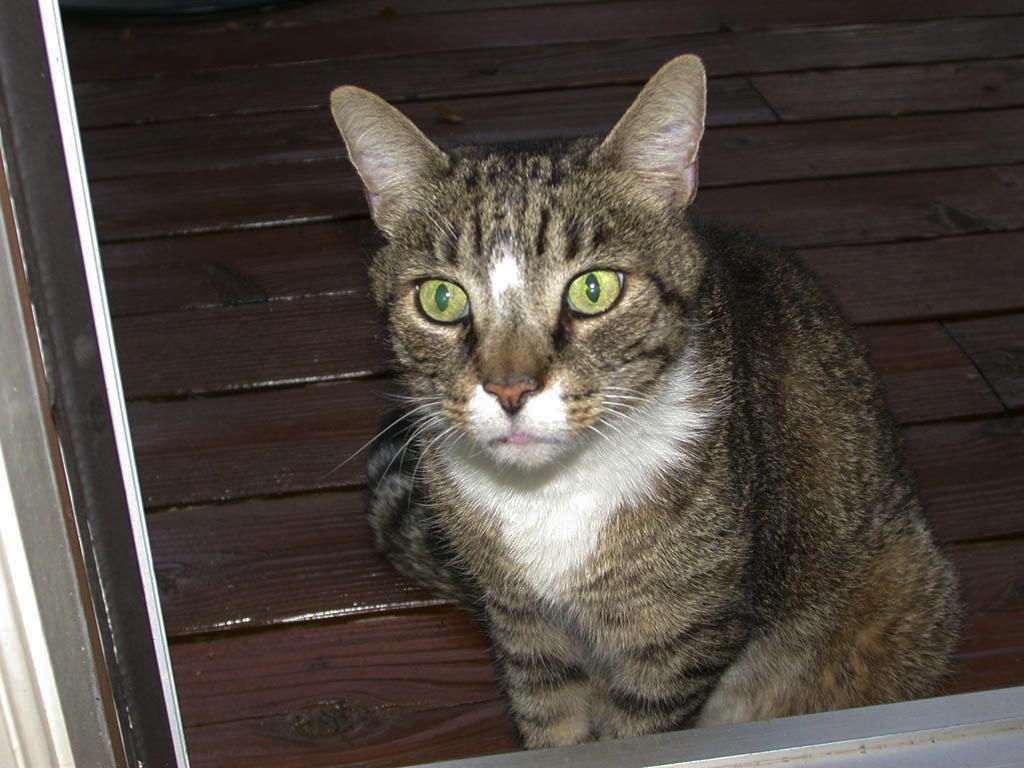What type of animal is present in the image? There is a cat in the image. Where is the cat located in the image? The cat is sitting on the wooden floor. What can be seen in the background of the image? There is a window frame in the image. How many fingers can be seen touching the cat in the image? There are no fingers touching the cat in the image. What type of pollution is visible in the image? There is no pollution visible in the image; it features a cat sitting on a wooden floor with a window frame in the background. 